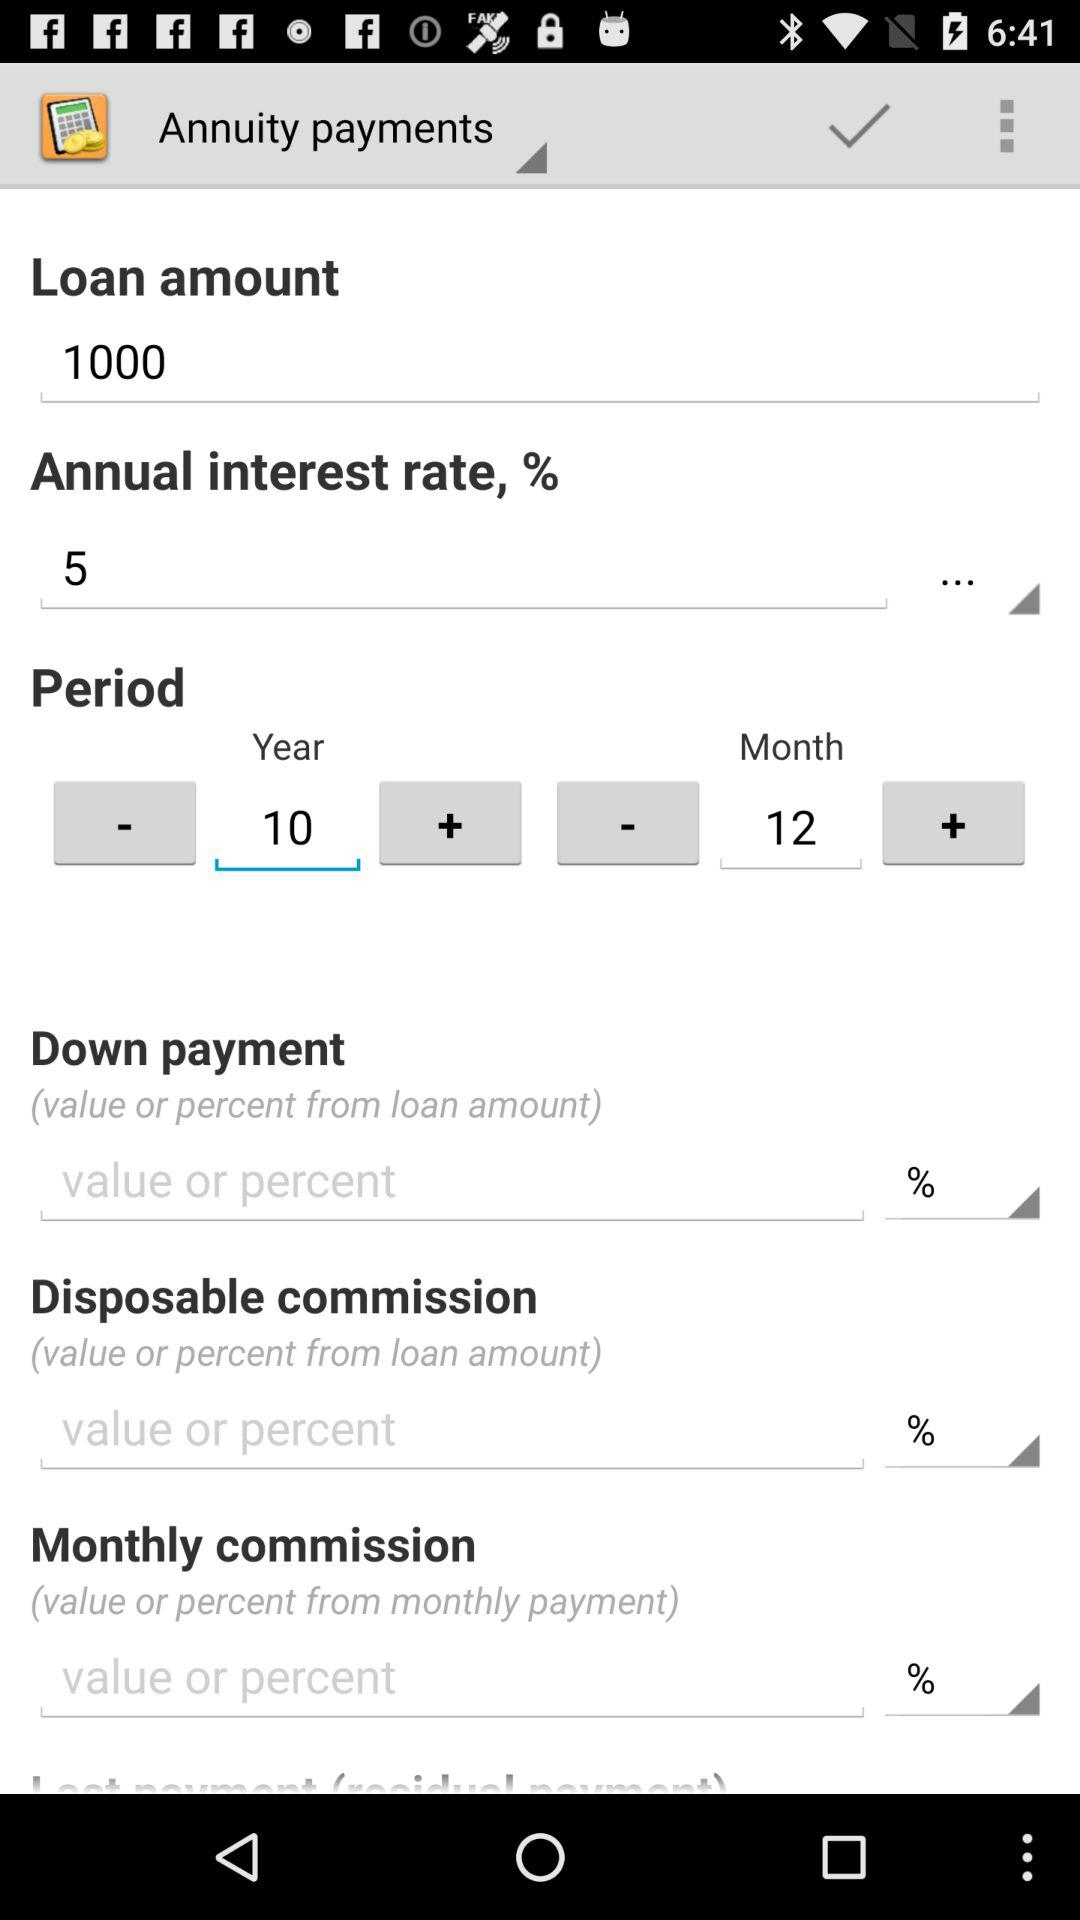Which tab is currently opened? The tab is "Annuity payments". 